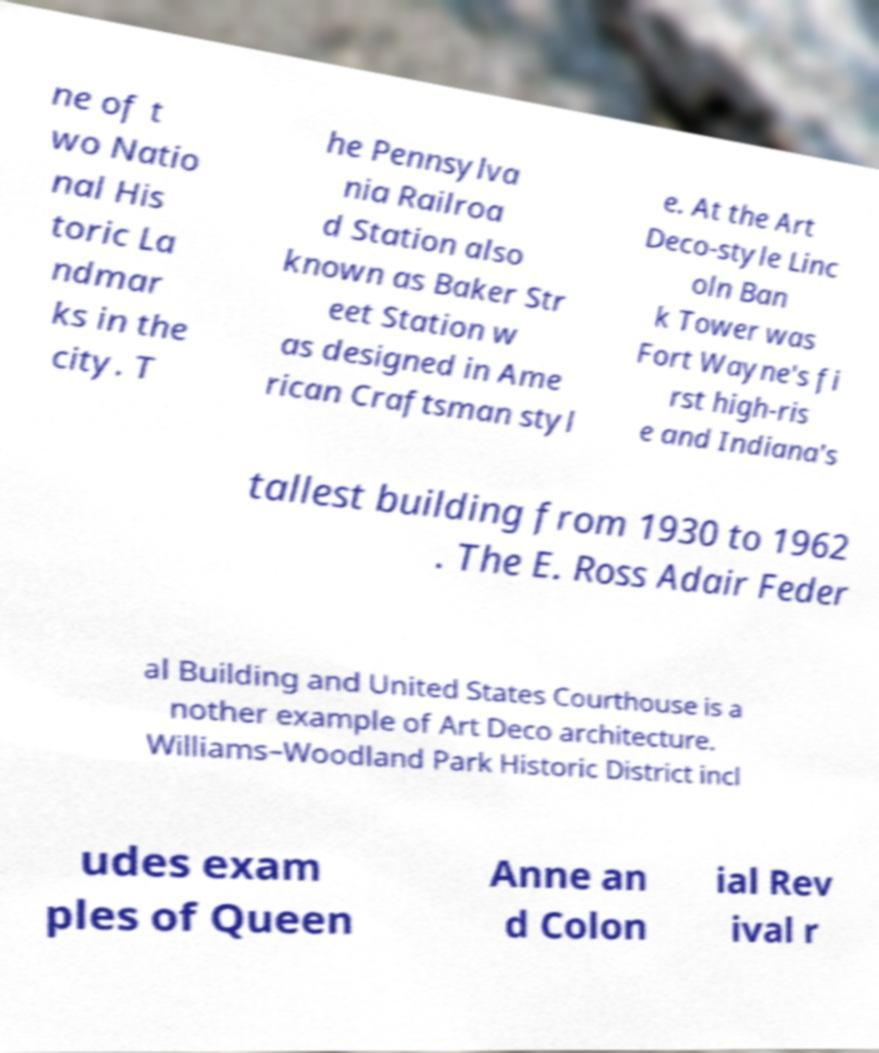Could you assist in decoding the text presented in this image and type it out clearly? ne of t wo Natio nal His toric La ndmar ks in the city. T he Pennsylva nia Railroa d Station also known as Baker Str eet Station w as designed in Ame rican Craftsman styl e. At the Art Deco-style Linc oln Ban k Tower was Fort Wayne's fi rst high-ris e and Indiana's tallest building from 1930 to 1962 . The E. Ross Adair Feder al Building and United States Courthouse is a nother example of Art Deco architecture. Williams–Woodland Park Historic District incl udes exam ples of Queen Anne an d Colon ial Rev ival r 